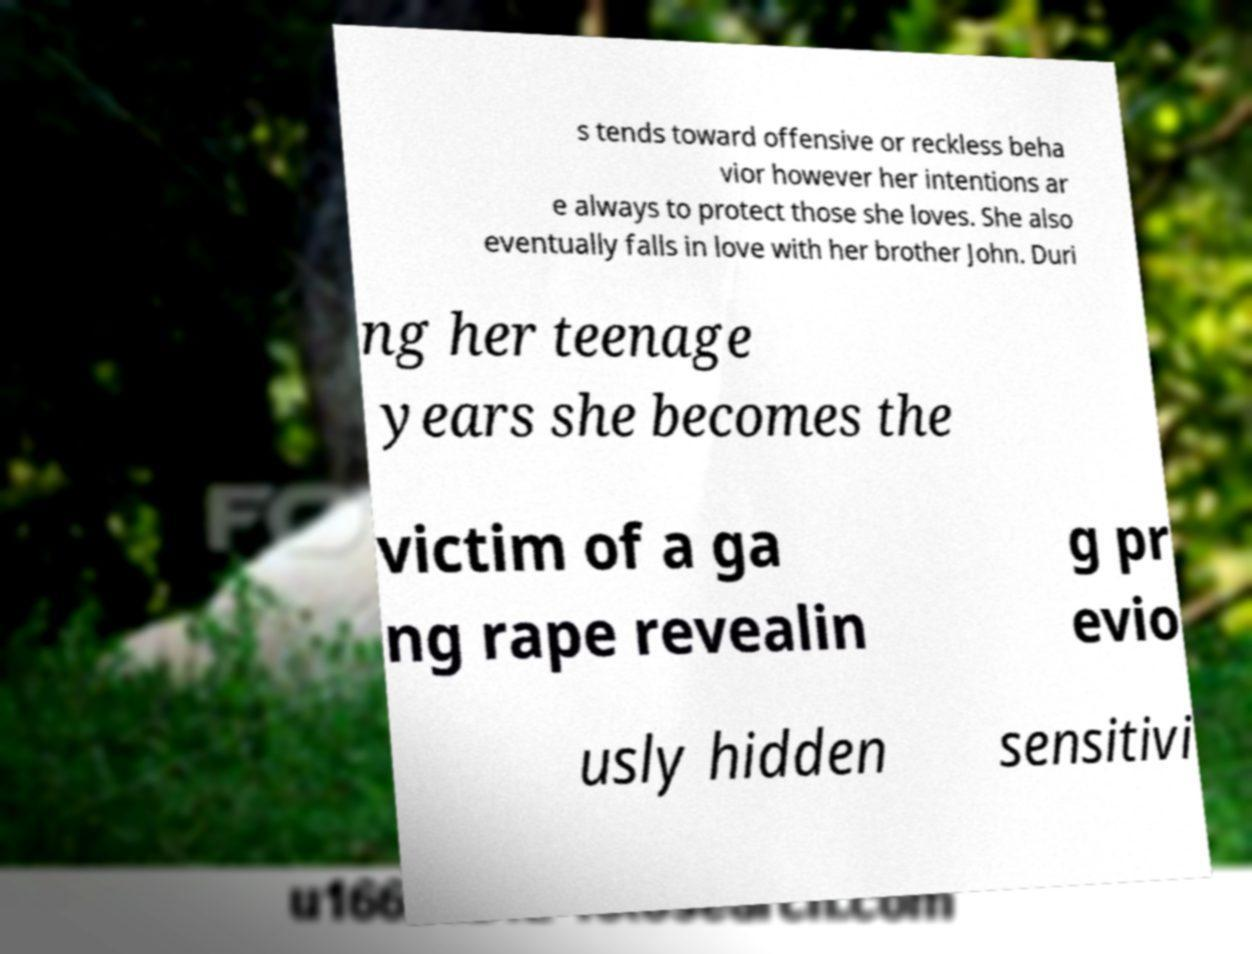For documentation purposes, I need the text within this image transcribed. Could you provide that? s tends toward offensive or reckless beha vior however her intentions ar e always to protect those she loves. She also eventually falls in love with her brother John. Duri ng her teenage years she becomes the victim of a ga ng rape revealin g pr evio usly hidden sensitivi 